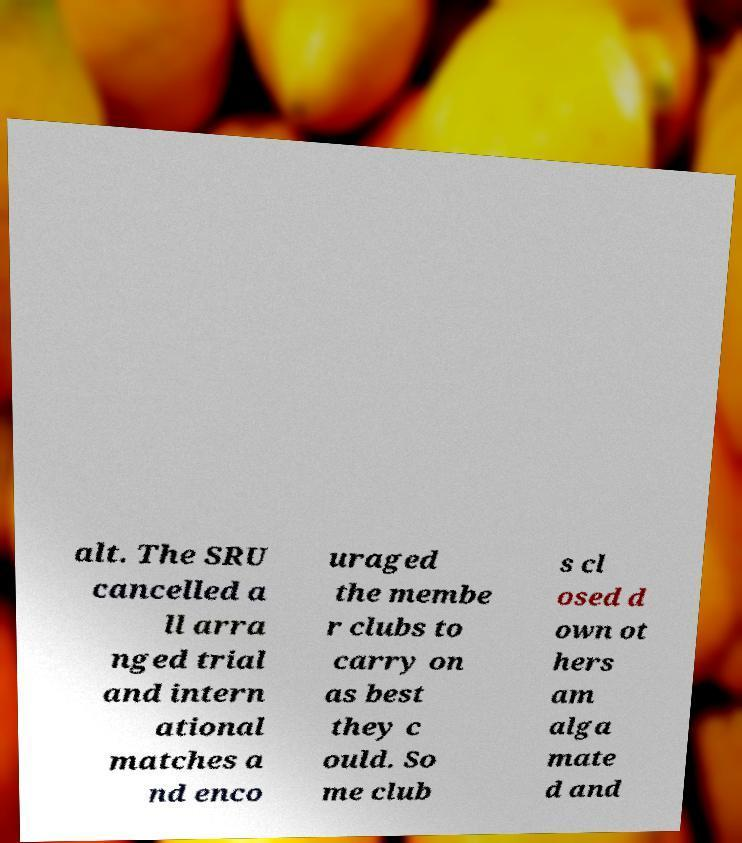There's text embedded in this image that I need extracted. Can you transcribe it verbatim? alt. The SRU cancelled a ll arra nged trial and intern ational matches a nd enco uraged the membe r clubs to carry on as best they c ould. So me club s cl osed d own ot hers am alga mate d and 